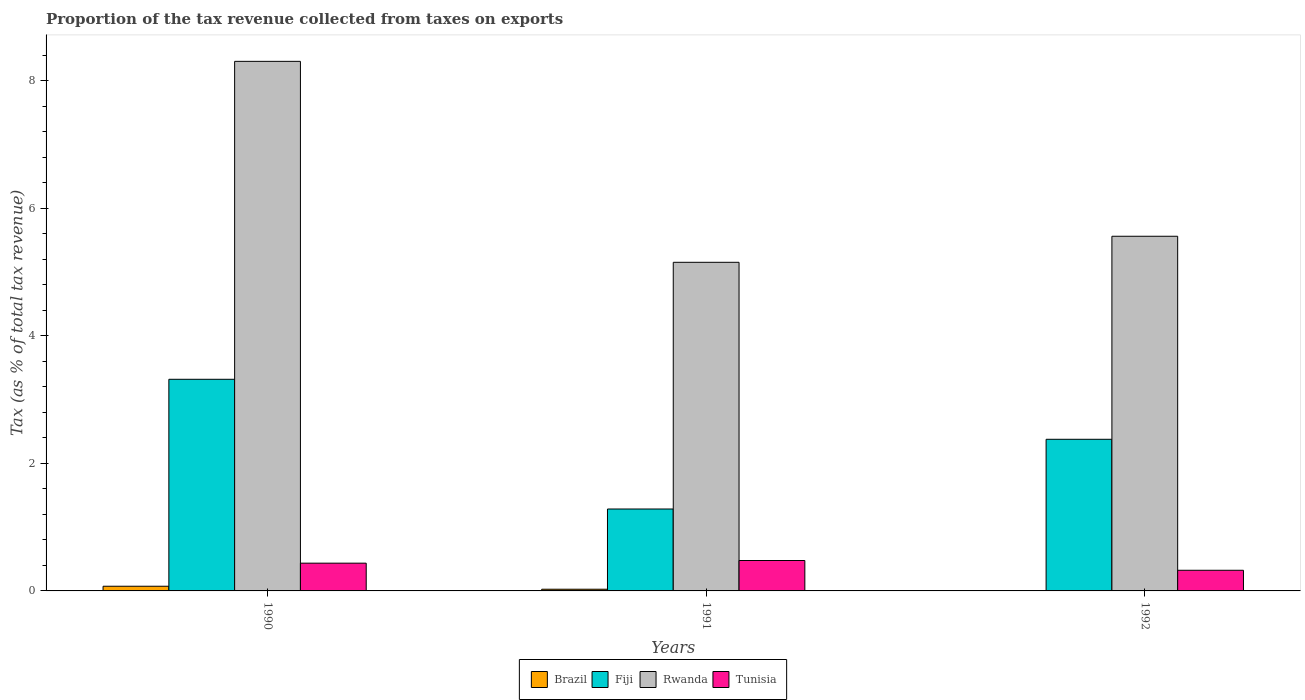How many different coloured bars are there?
Make the answer very short. 4. How many groups of bars are there?
Your answer should be compact. 3. Are the number of bars on each tick of the X-axis equal?
Provide a short and direct response. Yes. How many bars are there on the 1st tick from the left?
Offer a terse response. 4. How many bars are there on the 2nd tick from the right?
Offer a terse response. 4. What is the label of the 2nd group of bars from the left?
Offer a very short reply. 1991. In how many cases, is the number of bars for a given year not equal to the number of legend labels?
Offer a very short reply. 0. What is the proportion of the tax revenue collected in Rwanda in 1992?
Your answer should be very brief. 5.56. Across all years, what is the maximum proportion of the tax revenue collected in Brazil?
Offer a very short reply. 0.07. Across all years, what is the minimum proportion of the tax revenue collected in Rwanda?
Provide a succinct answer. 5.16. In which year was the proportion of the tax revenue collected in Brazil maximum?
Give a very brief answer. 1990. In which year was the proportion of the tax revenue collected in Tunisia minimum?
Offer a terse response. 1992. What is the total proportion of the tax revenue collected in Tunisia in the graph?
Offer a terse response. 1.24. What is the difference between the proportion of the tax revenue collected in Rwanda in 1991 and that in 1992?
Offer a terse response. -0.41. What is the difference between the proportion of the tax revenue collected in Rwanda in 1991 and the proportion of the tax revenue collected in Brazil in 1990?
Keep it short and to the point. 5.08. What is the average proportion of the tax revenue collected in Rwanda per year?
Keep it short and to the point. 6.34. In the year 1992, what is the difference between the proportion of the tax revenue collected in Rwanda and proportion of the tax revenue collected in Brazil?
Your answer should be compact. 5.56. What is the ratio of the proportion of the tax revenue collected in Rwanda in 1990 to that in 1992?
Offer a very short reply. 1.49. Is the proportion of the tax revenue collected in Fiji in 1991 less than that in 1992?
Offer a terse response. Yes. What is the difference between the highest and the second highest proportion of the tax revenue collected in Fiji?
Provide a short and direct response. 0.94. What is the difference between the highest and the lowest proportion of the tax revenue collected in Tunisia?
Offer a very short reply. 0.15. In how many years, is the proportion of the tax revenue collected in Tunisia greater than the average proportion of the tax revenue collected in Tunisia taken over all years?
Offer a very short reply. 2. Is it the case that in every year, the sum of the proportion of the tax revenue collected in Rwanda and proportion of the tax revenue collected in Fiji is greater than the sum of proportion of the tax revenue collected in Tunisia and proportion of the tax revenue collected in Brazil?
Make the answer very short. Yes. What does the 2nd bar from the left in 1990 represents?
Offer a very short reply. Fiji. What does the 2nd bar from the right in 1990 represents?
Your answer should be very brief. Rwanda. Is it the case that in every year, the sum of the proportion of the tax revenue collected in Rwanda and proportion of the tax revenue collected in Tunisia is greater than the proportion of the tax revenue collected in Brazil?
Ensure brevity in your answer.  Yes. Are all the bars in the graph horizontal?
Provide a succinct answer. No. How many years are there in the graph?
Ensure brevity in your answer.  3. Where does the legend appear in the graph?
Your answer should be very brief. Bottom center. How are the legend labels stacked?
Your answer should be compact. Horizontal. What is the title of the graph?
Ensure brevity in your answer.  Proportion of the tax revenue collected from taxes on exports. Does "Uruguay" appear as one of the legend labels in the graph?
Give a very brief answer. No. What is the label or title of the X-axis?
Provide a short and direct response. Years. What is the label or title of the Y-axis?
Give a very brief answer. Tax (as % of total tax revenue). What is the Tax (as % of total tax revenue) of Brazil in 1990?
Offer a terse response. 0.07. What is the Tax (as % of total tax revenue) of Fiji in 1990?
Give a very brief answer. 3.32. What is the Tax (as % of total tax revenue) of Rwanda in 1990?
Provide a succinct answer. 8.31. What is the Tax (as % of total tax revenue) in Tunisia in 1990?
Ensure brevity in your answer.  0.44. What is the Tax (as % of total tax revenue) of Brazil in 1991?
Give a very brief answer. 0.03. What is the Tax (as % of total tax revenue) of Fiji in 1991?
Give a very brief answer. 1.29. What is the Tax (as % of total tax revenue) in Rwanda in 1991?
Give a very brief answer. 5.16. What is the Tax (as % of total tax revenue) in Tunisia in 1991?
Your answer should be very brief. 0.48. What is the Tax (as % of total tax revenue) of Brazil in 1992?
Make the answer very short. 0. What is the Tax (as % of total tax revenue) in Fiji in 1992?
Provide a short and direct response. 2.38. What is the Tax (as % of total tax revenue) of Rwanda in 1992?
Your answer should be very brief. 5.56. What is the Tax (as % of total tax revenue) of Tunisia in 1992?
Keep it short and to the point. 0.32. Across all years, what is the maximum Tax (as % of total tax revenue) of Brazil?
Offer a terse response. 0.07. Across all years, what is the maximum Tax (as % of total tax revenue) of Fiji?
Keep it short and to the point. 3.32. Across all years, what is the maximum Tax (as % of total tax revenue) of Rwanda?
Your response must be concise. 8.31. Across all years, what is the maximum Tax (as % of total tax revenue) in Tunisia?
Provide a short and direct response. 0.48. Across all years, what is the minimum Tax (as % of total tax revenue) in Brazil?
Your answer should be compact. 0. Across all years, what is the minimum Tax (as % of total tax revenue) in Fiji?
Provide a short and direct response. 1.29. Across all years, what is the minimum Tax (as % of total tax revenue) in Rwanda?
Give a very brief answer. 5.16. Across all years, what is the minimum Tax (as % of total tax revenue) in Tunisia?
Your response must be concise. 0.32. What is the total Tax (as % of total tax revenue) of Brazil in the graph?
Offer a very short reply. 0.1. What is the total Tax (as % of total tax revenue) of Fiji in the graph?
Make the answer very short. 6.98. What is the total Tax (as % of total tax revenue) of Rwanda in the graph?
Your answer should be very brief. 19.03. What is the total Tax (as % of total tax revenue) of Tunisia in the graph?
Ensure brevity in your answer.  1.24. What is the difference between the Tax (as % of total tax revenue) in Brazil in 1990 and that in 1991?
Keep it short and to the point. 0.05. What is the difference between the Tax (as % of total tax revenue) in Fiji in 1990 and that in 1991?
Offer a very short reply. 2.03. What is the difference between the Tax (as % of total tax revenue) of Rwanda in 1990 and that in 1991?
Offer a terse response. 3.15. What is the difference between the Tax (as % of total tax revenue) in Tunisia in 1990 and that in 1991?
Ensure brevity in your answer.  -0.04. What is the difference between the Tax (as % of total tax revenue) of Brazil in 1990 and that in 1992?
Provide a succinct answer. 0.07. What is the difference between the Tax (as % of total tax revenue) of Fiji in 1990 and that in 1992?
Your response must be concise. 0.94. What is the difference between the Tax (as % of total tax revenue) in Rwanda in 1990 and that in 1992?
Provide a short and direct response. 2.74. What is the difference between the Tax (as % of total tax revenue) in Tunisia in 1990 and that in 1992?
Your response must be concise. 0.11. What is the difference between the Tax (as % of total tax revenue) in Brazil in 1991 and that in 1992?
Ensure brevity in your answer.  0.02. What is the difference between the Tax (as % of total tax revenue) in Fiji in 1991 and that in 1992?
Give a very brief answer. -1.09. What is the difference between the Tax (as % of total tax revenue) of Rwanda in 1991 and that in 1992?
Provide a succinct answer. -0.41. What is the difference between the Tax (as % of total tax revenue) of Tunisia in 1991 and that in 1992?
Offer a very short reply. 0.15. What is the difference between the Tax (as % of total tax revenue) in Brazil in 1990 and the Tax (as % of total tax revenue) in Fiji in 1991?
Your answer should be compact. -1.21. What is the difference between the Tax (as % of total tax revenue) of Brazil in 1990 and the Tax (as % of total tax revenue) of Rwanda in 1991?
Make the answer very short. -5.08. What is the difference between the Tax (as % of total tax revenue) of Brazil in 1990 and the Tax (as % of total tax revenue) of Tunisia in 1991?
Keep it short and to the point. -0.4. What is the difference between the Tax (as % of total tax revenue) in Fiji in 1990 and the Tax (as % of total tax revenue) in Rwanda in 1991?
Keep it short and to the point. -1.84. What is the difference between the Tax (as % of total tax revenue) of Fiji in 1990 and the Tax (as % of total tax revenue) of Tunisia in 1991?
Keep it short and to the point. 2.84. What is the difference between the Tax (as % of total tax revenue) in Rwanda in 1990 and the Tax (as % of total tax revenue) in Tunisia in 1991?
Your answer should be compact. 7.83. What is the difference between the Tax (as % of total tax revenue) in Brazil in 1990 and the Tax (as % of total tax revenue) in Fiji in 1992?
Your answer should be very brief. -2.31. What is the difference between the Tax (as % of total tax revenue) of Brazil in 1990 and the Tax (as % of total tax revenue) of Rwanda in 1992?
Provide a succinct answer. -5.49. What is the difference between the Tax (as % of total tax revenue) in Brazil in 1990 and the Tax (as % of total tax revenue) in Tunisia in 1992?
Your response must be concise. -0.25. What is the difference between the Tax (as % of total tax revenue) in Fiji in 1990 and the Tax (as % of total tax revenue) in Rwanda in 1992?
Ensure brevity in your answer.  -2.24. What is the difference between the Tax (as % of total tax revenue) of Fiji in 1990 and the Tax (as % of total tax revenue) of Tunisia in 1992?
Keep it short and to the point. 3. What is the difference between the Tax (as % of total tax revenue) of Rwanda in 1990 and the Tax (as % of total tax revenue) of Tunisia in 1992?
Offer a very short reply. 7.98. What is the difference between the Tax (as % of total tax revenue) in Brazil in 1991 and the Tax (as % of total tax revenue) in Fiji in 1992?
Give a very brief answer. -2.35. What is the difference between the Tax (as % of total tax revenue) in Brazil in 1991 and the Tax (as % of total tax revenue) in Rwanda in 1992?
Offer a very short reply. -5.54. What is the difference between the Tax (as % of total tax revenue) in Brazil in 1991 and the Tax (as % of total tax revenue) in Tunisia in 1992?
Ensure brevity in your answer.  -0.3. What is the difference between the Tax (as % of total tax revenue) in Fiji in 1991 and the Tax (as % of total tax revenue) in Rwanda in 1992?
Ensure brevity in your answer.  -4.28. What is the difference between the Tax (as % of total tax revenue) of Fiji in 1991 and the Tax (as % of total tax revenue) of Tunisia in 1992?
Make the answer very short. 0.96. What is the difference between the Tax (as % of total tax revenue) in Rwanda in 1991 and the Tax (as % of total tax revenue) in Tunisia in 1992?
Provide a succinct answer. 4.83. What is the average Tax (as % of total tax revenue) of Brazil per year?
Your answer should be compact. 0.03. What is the average Tax (as % of total tax revenue) of Fiji per year?
Keep it short and to the point. 2.33. What is the average Tax (as % of total tax revenue) in Rwanda per year?
Your response must be concise. 6.34. What is the average Tax (as % of total tax revenue) of Tunisia per year?
Give a very brief answer. 0.41. In the year 1990, what is the difference between the Tax (as % of total tax revenue) of Brazil and Tax (as % of total tax revenue) of Fiji?
Your answer should be very brief. -3.25. In the year 1990, what is the difference between the Tax (as % of total tax revenue) in Brazil and Tax (as % of total tax revenue) in Rwanda?
Ensure brevity in your answer.  -8.23. In the year 1990, what is the difference between the Tax (as % of total tax revenue) in Brazil and Tax (as % of total tax revenue) in Tunisia?
Provide a short and direct response. -0.36. In the year 1990, what is the difference between the Tax (as % of total tax revenue) in Fiji and Tax (as % of total tax revenue) in Rwanda?
Offer a terse response. -4.99. In the year 1990, what is the difference between the Tax (as % of total tax revenue) in Fiji and Tax (as % of total tax revenue) in Tunisia?
Offer a very short reply. 2.88. In the year 1990, what is the difference between the Tax (as % of total tax revenue) in Rwanda and Tax (as % of total tax revenue) in Tunisia?
Your response must be concise. 7.87. In the year 1991, what is the difference between the Tax (as % of total tax revenue) of Brazil and Tax (as % of total tax revenue) of Fiji?
Keep it short and to the point. -1.26. In the year 1991, what is the difference between the Tax (as % of total tax revenue) in Brazil and Tax (as % of total tax revenue) in Rwanda?
Your answer should be compact. -5.13. In the year 1991, what is the difference between the Tax (as % of total tax revenue) in Brazil and Tax (as % of total tax revenue) in Tunisia?
Ensure brevity in your answer.  -0.45. In the year 1991, what is the difference between the Tax (as % of total tax revenue) in Fiji and Tax (as % of total tax revenue) in Rwanda?
Offer a very short reply. -3.87. In the year 1991, what is the difference between the Tax (as % of total tax revenue) of Fiji and Tax (as % of total tax revenue) of Tunisia?
Your answer should be very brief. 0.81. In the year 1991, what is the difference between the Tax (as % of total tax revenue) in Rwanda and Tax (as % of total tax revenue) in Tunisia?
Your answer should be compact. 4.68. In the year 1992, what is the difference between the Tax (as % of total tax revenue) in Brazil and Tax (as % of total tax revenue) in Fiji?
Your answer should be very brief. -2.38. In the year 1992, what is the difference between the Tax (as % of total tax revenue) of Brazil and Tax (as % of total tax revenue) of Rwanda?
Provide a short and direct response. -5.56. In the year 1992, what is the difference between the Tax (as % of total tax revenue) in Brazil and Tax (as % of total tax revenue) in Tunisia?
Ensure brevity in your answer.  -0.32. In the year 1992, what is the difference between the Tax (as % of total tax revenue) of Fiji and Tax (as % of total tax revenue) of Rwanda?
Your response must be concise. -3.19. In the year 1992, what is the difference between the Tax (as % of total tax revenue) of Fiji and Tax (as % of total tax revenue) of Tunisia?
Make the answer very short. 2.05. In the year 1992, what is the difference between the Tax (as % of total tax revenue) of Rwanda and Tax (as % of total tax revenue) of Tunisia?
Offer a terse response. 5.24. What is the ratio of the Tax (as % of total tax revenue) of Brazil in 1990 to that in 1991?
Provide a succinct answer. 2.76. What is the ratio of the Tax (as % of total tax revenue) in Fiji in 1990 to that in 1991?
Provide a succinct answer. 2.58. What is the ratio of the Tax (as % of total tax revenue) in Rwanda in 1990 to that in 1991?
Keep it short and to the point. 1.61. What is the ratio of the Tax (as % of total tax revenue) of Tunisia in 1990 to that in 1991?
Provide a succinct answer. 0.91. What is the ratio of the Tax (as % of total tax revenue) of Brazil in 1990 to that in 1992?
Ensure brevity in your answer.  38.17. What is the ratio of the Tax (as % of total tax revenue) of Fiji in 1990 to that in 1992?
Keep it short and to the point. 1.4. What is the ratio of the Tax (as % of total tax revenue) of Rwanda in 1990 to that in 1992?
Your answer should be very brief. 1.49. What is the ratio of the Tax (as % of total tax revenue) in Tunisia in 1990 to that in 1992?
Provide a short and direct response. 1.34. What is the ratio of the Tax (as % of total tax revenue) of Brazil in 1991 to that in 1992?
Your response must be concise. 13.82. What is the ratio of the Tax (as % of total tax revenue) in Fiji in 1991 to that in 1992?
Provide a succinct answer. 0.54. What is the ratio of the Tax (as % of total tax revenue) of Rwanda in 1991 to that in 1992?
Give a very brief answer. 0.93. What is the ratio of the Tax (as % of total tax revenue) of Tunisia in 1991 to that in 1992?
Provide a succinct answer. 1.47. What is the difference between the highest and the second highest Tax (as % of total tax revenue) of Brazil?
Your answer should be very brief. 0.05. What is the difference between the highest and the second highest Tax (as % of total tax revenue) in Fiji?
Offer a very short reply. 0.94. What is the difference between the highest and the second highest Tax (as % of total tax revenue) in Rwanda?
Your response must be concise. 2.74. What is the difference between the highest and the second highest Tax (as % of total tax revenue) in Tunisia?
Ensure brevity in your answer.  0.04. What is the difference between the highest and the lowest Tax (as % of total tax revenue) in Brazil?
Your response must be concise. 0.07. What is the difference between the highest and the lowest Tax (as % of total tax revenue) of Fiji?
Provide a succinct answer. 2.03. What is the difference between the highest and the lowest Tax (as % of total tax revenue) in Rwanda?
Give a very brief answer. 3.15. What is the difference between the highest and the lowest Tax (as % of total tax revenue) in Tunisia?
Provide a succinct answer. 0.15. 